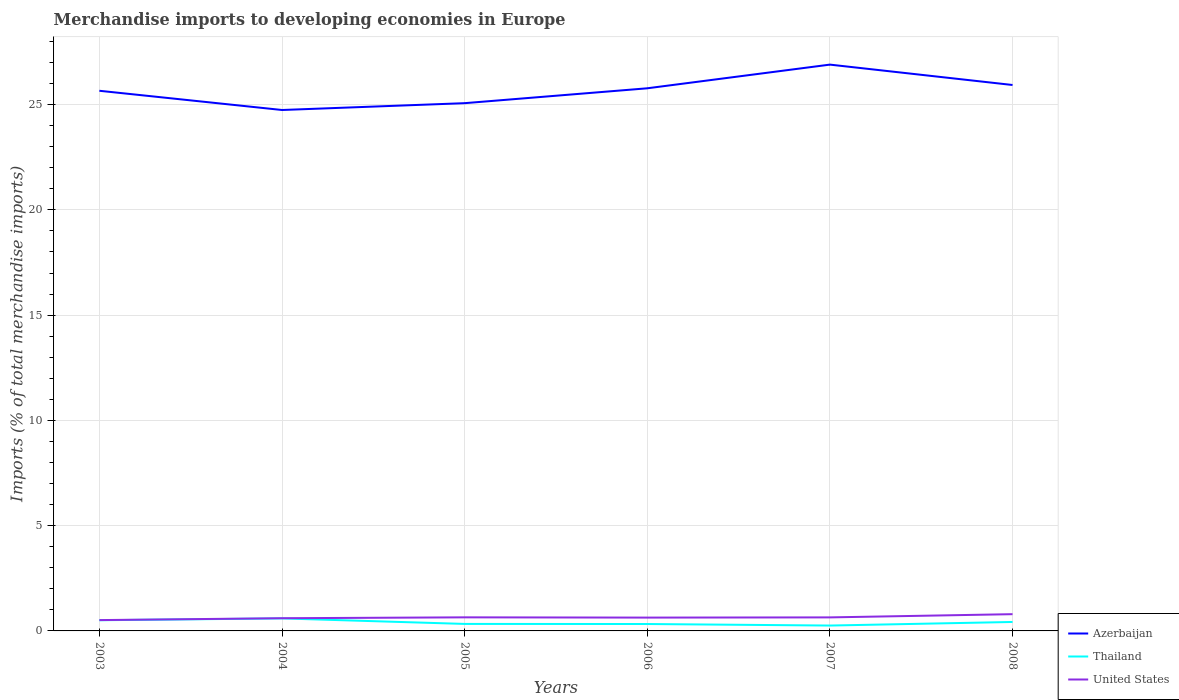Does the line corresponding to Azerbaijan intersect with the line corresponding to Thailand?
Give a very brief answer. No. Is the number of lines equal to the number of legend labels?
Provide a succinct answer. Yes. Across all years, what is the maximum percentage total merchandise imports in Thailand?
Provide a short and direct response. 0.26. In which year was the percentage total merchandise imports in Thailand maximum?
Ensure brevity in your answer.  2007. What is the total percentage total merchandise imports in United States in the graph?
Provide a short and direct response. -0.16. What is the difference between the highest and the second highest percentage total merchandise imports in United States?
Give a very brief answer. 0.28. What is the difference between the highest and the lowest percentage total merchandise imports in Azerbaijan?
Make the answer very short. 3. Is the percentage total merchandise imports in Azerbaijan strictly greater than the percentage total merchandise imports in Thailand over the years?
Give a very brief answer. No. How many lines are there?
Provide a succinct answer. 3. Are the values on the major ticks of Y-axis written in scientific E-notation?
Your answer should be compact. No. How many legend labels are there?
Give a very brief answer. 3. How are the legend labels stacked?
Provide a succinct answer. Vertical. What is the title of the graph?
Ensure brevity in your answer.  Merchandise imports to developing economies in Europe. What is the label or title of the Y-axis?
Offer a very short reply. Imports (% of total merchandise imports). What is the Imports (% of total merchandise imports) in Azerbaijan in 2003?
Provide a succinct answer. 25.66. What is the Imports (% of total merchandise imports) in Thailand in 2003?
Provide a short and direct response. 0.51. What is the Imports (% of total merchandise imports) of United States in 2003?
Your response must be concise. 0.51. What is the Imports (% of total merchandise imports) in Azerbaijan in 2004?
Give a very brief answer. 24.74. What is the Imports (% of total merchandise imports) in Thailand in 2004?
Provide a short and direct response. 0.59. What is the Imports (% of total merchandise imports) in United States in 2004?
Keep it short and to the point. 0.6. What is the Imports (% of total merchandise imports) of Azerbaijan in 2005?
Keep it short and to the point. 25.07. What is the Imports (% of total merchandise imports) of Thailand in 2005?
Provide a succinct answer. 0.33. What is the Imports (% of total merchandise imports) of United States in 2005?
Your response must be concise. 0.65. What is the Imports (% of total merchandise imports) of Azerbaijan in 2006?
Offer a terse response. 25.77. What is the Imports (% of total merchandise imports) in Thailand in 2006?
Offer a very short reply. 0.33. What is the Imports (% of total merchandise imports) in United States in 2006?
Your answer should be compact. 0.63. What is the Imports (% of total merchandise imports) in Azerbaijan in 2007?
Make the answer very short. 26.9. What is the Imports (% of total merchandise imports) in Thailand in 2007?
Your response must be concise. 0.26. What is the Imports (% of total merchandise imports) of United States in 2007?
Your answer should be compact. 0.64. What is the Imports (% of total merchandise imports) in Azerbaijan in 2008?
Make the answer very short. 25.93. What is the Imports (% of total merchandise imports) in Thailand in 2008?
Provide a succinct answer. 0.43. What is the Imports (% of total merchandise imports) of United States in 2008?
Your answer should be compact. 0.8. Across all years, what is the maximum Imports (% of total merchandise imports) of Azerbaijan?
Your response must be concise. 26.9. Across all years, what is the maximum Imports (% of total merchandise imports) of Thailand?
Give a very brief answer. 0.59. Across all years, what is the maximum Imports (% of total merchandise imports) of United States?
Ensure brevity in your answer.  0.8. Across all years, what is the minimum Imports (% of total merchandise imports) in Azerbaijan?
Provide a succinct answer. 24.74. Across all years, what is the minimum Imports (% of total merchandise imports) in Thailand?
Your response must be concise. 0.26. Across all years, what is the minimum Imports (% of total merchandise imports) of United States?
Give a very brief answer. 0.51. What is the total Imports (% of total merchandise imports) in Azerbaijan in the graph?
Give a very brief answer. 154.07. What is the total Imports (% of total merchandise imports) of Thailand in the graph?
Keep it short and to the point. 2.44. What is the total Imports (% of total merchandise imports) in United States in the graph?
Give a very brief answer. 3.83. What is the difference between the Imports (% of total merchandise imports) of Azerbaijan in 2003 and that in 2004?
Your response must be concise. 0.91. What is the difference between the Imports (% of total merchandise imports) in Thailand in 2003 and that in 2004?
Your response must be concise. -0.09. What is the difference between the Imports (% of total merchandise imports) in United States in 2003 and that in 2004?
Your response must be concise. -0.09. What is the difference between the Imports (% of total merchandise imports) of Azerbaijan in 2003 and that in 2005?
Ensure brevity in your answer.  0.59. What is the difference between the Imports (% of total merchandise imports) in Thailand in 2003 and that in 2005?
Ensure brevity in your answer.  0.18. What is the difference between the Imports (% of total merchandise imports) of United States in 2003 and that in 2005?
Provide a short and direct response. -0.13. What is the difference between the Imports (% of total merchandise imports) of Azerbaijan in 2003 and that in 2006?
Provide a short and direct response. -0.12. What is the difference between the Imports (% of total merchandise imports) in Thailand in 2003 and that in 2006?
Your response must be concise. 0.18. What is the difference between the Imports (% of total merchandise imports) in United States in 2003 and that in 2006?
Your response must be concise. -0.12. What is the difference between the Imports (% of total merchandise imports) in Azerbaijan in 2003 and that in 2007?
Offer a very short reply. -1.24. What is the difference between the Imports (% of total merchandise imports) in Thailand in 2003 and that in 2007?
Ensure brevity in your answer.  0.25. What is the difference between the Imports (% of total merchandise imports) in United States in 2003 and that in 2007?
Your answer should be compact. -0.13. What is the difference between the Imports (% of total merchandise imports) of Azerbaijan in 2003 and that in 2008?
Ensure brevity in your answer.  -0.27. What is the difference between the Imports (% of total merchandise imports) in Thailand in 2003 and that in 2008?
Offer a very short reply. 0.08. What is the difference between the Imports (% of total merchandise imports) of United States in 2003 and that in 2008?
Make the answer very short. -0.28. What is the difference between the Imports (% of total merchandise imports) in Azerbaijan in 2004 and that in 2005?
Your answer should be very brief. -0.32. What is the difference between the Imports (% of total merchandise imports) in Thailand in 2004 and that in 2005?
Keep it short and to the point. 0.26. What is the difference between the Imports (% of total merchandise imports) in United States in 2004 and that in 2005?
Your answer should be very brief. -0.04. What is the difference between the Imports (% of total merchandise imports) in Azerbaijan in 2004 and that in 2006?
Give a very brief answer. -1.03. What is the difference between the Imports (% of total merchandise imports) of Thailand in 2004 and that in 2006?
Provide a succinct answer. 0.27. What is the difference between the Imports (% of total merchandise imports) of United States in 2004 and that in 2006?
Your response must be concise. -0.03. What is the difference between the Imports (% of total merchandise imports) in Azerbaijan in 2004 and that in 2007?
Ensure brevity in your answer.  -2.16. What is the difference between the Imports (% of total merchandise imports) of Thailand in 2004 and that in 2007?
Your response must be concise. 0.34. What is the difference between the Imports (% of total merchandise imports) of United States in 2004 and that in 2007?
Provide a short and direct response. -0.04. What is the difference between the Imports (% of total merchandise imports) of Azerbaijan in 2004 and that in 2008?
Make the answer very short. -1.19. What is the difference between the Imports (% of total merchandise imports) in Thailand in 2004 and that in 2008?
Provide a short and direct response. 0.17. What is the difference between the Imports (% of total merchandise imports) in United States in 2004 and that in 2008?
Provide a succinct answer. -0.19. What is the difference between the Imports (% of total merchandise imports) in Azerbaijan in 2005 and that in 2006?
Ensure brevity in your answer.  -0.71. What is the difference between the Imports (% of total merchandise imports) in Thailand in 2005 and that in 2006?
Keep it short and to the point. 0. What is the difference between the Imports (% of total merchandise imports) in United States in 2005 and that in 2006?
Make the answer very short. 0.01. What is the difference between the Imports (% of total merchandise imports) of Azerbaijan in 2005 and that in 2007?
Your response must be concise. -1.83. What is the difference between the Imports (% of total merchandise imports) in Thailand in 2005 and that in 2007?
Ensure brevity in your answer.  0.08. What is the difference between the Imports (% of total merchandise imports) in United States in 2005 and that in 2007?
Offer a very short reply. 0. What is the difference between the Imports (% of total merchandise imports) of Azerbaijan in 2005 and that in 2008?
Offer a very short reply. -0.86. What is the difference between the Imports (% of total merchandise imports) of Thailand in 2005 and that in 2008?
Your answer should be compact. -0.09. What is the difference between the Imports (% of total merchandise imports) in United States in 2005 and that in 2008?
Ensure brevity in your answer.  -0.15. What is the difference between the Imports (% of total merchandise imports) of Azerbaijan in 2006 and that in 2007?
Your answer should be compact. -1.12. What is the difference between the Imports (% of total merchandise imports) in Thailand in 2006 and that in 2007?
Your answer should be very brief. 0.07. What is the difference between the Imports (% of total merchandise imports) of United States in 2006 and that in 2007?
Offer a very short reply. -0.01. What is the difference between the Imports (% of total merchandise imports) in Azerbaijan in 2006 and that in 2008?
Your answer should be compact. -0.16. What is the difference between the Imports (% of total merchandise imports) in Thailand in 2006 and that in 2008?
Your answer should be compact. -0.1. What is the difference between the Imports (% of total merchandise imports) of United States in 2006 and that in 2008?
Your answer should be very brief. -0.16. What is the difference between the Imports (% of total merchandise imports) of Azerbaijan in 2007 and that in 2008?
Provide a succinct answer. 0.97. What is the difference between the Imports (% of total merchandise imports) of Thailand in 2007 and that in 2008?
Offer a very short reply. -0.17. What is the difference between the Imports (% of total merchandise imports) in United States in 2007 and that in 2008?
Ensure brevity in your answer.  -0.15. What is the difference between the Imports (% of total merchandise imports) in Azerbaijan in 2003 and the Imports (% of total merchandise imports) in Thailand in 2004?
Your answer should be very brief. 25.06. What is the difference between the Imports (% of total merchandise imports) in Azerbaijan in 2003 and the Imports (% of total merchandise imports) in United States in 2004?
Offer a very short reply. 25.05. What is the difference between the Imports (% of total merchandise imports) of Thailand in 2003 and the Imports (% of total merchandise imports) of United States in 2004?
Your response must be concise. -0.1. What is the difference between the Imports (% of total merchandise imports) in Azerbaijan in 2003 and the Imports (% of total merchandise imports) in Thailand in 2005?
Ensure brevity in your answer.  25.32. What is the difference between the Imports (% of total merchandise imports) in Azerbaijan in 2003 and the Imports (% of total merchandise imports) in United States in 2005?
Offer a terse response. 25.01. What is the difference between the Imports (% of total merchandise imports) of Thailand in 2003 and the Imports (% of total merchandise imports) of United States in 2005?
Provide a short and direct response. -0.14. What is the difference between the Imports (% of total merchandise imports) in Azerbaijan in 2003 and the Imports (% of total merchandise imports) in Thailand in 2006?
Your answer should be compact. 25.33. What is the difference between the Imports (% of total merchandise imports) of Azerbaijan in 2003 and the Imports (% of total merchandise imports) of United States in 2006?
Ensure brevity in your answer.  25.02. What is the difference between the Imports (% of total merchandise imports) of Thailand in 2003 and the Imports (% of total merchandise imports) of United States in 2006?
Your answer should be very brief. -0.13. What is the difference between the Imports (% of total merchandise imports) in Azerbaijan in 2003 and the Imports (% of total merchandise imports) in Thailand in 2007?
Your answer should be compact. 25.4. What is the difference between the Imports (% of total merchandise imports) of Azerbaijan in 2003 and the Imports (% of total merchandise imports) of United States in 2007?
Keep it short and to the point. 25.01. What is the difference between the Imports (% of total merchandise imports) in Thailand in 2003 and the Imports (% of total merchandise imports) in United States in 2007?
Your answer should be very brief. -0.13. What is the difference between the Imports (% of total merchandise imports) of Azerbaijan in 2003 and the Imports (% of total merchandise imports) of Thailand in 2008?
Your answer should be compact. 25.23. What is the difference between the Imports (% of total merchandise imports) in Azerbaijan in 2003 and the Imports (% of total merchandise imports) in United States in 2008?
Give a very brief answer. 24.86. What is the difference between the Imports (% of total merchandise imports) of Thailand in 2003 and the Imports (% of total merchandise imports) of United States in 2008?
Offer a very short reply. -0.29. What is the difference between the Imports (% of total merchandise imports) of Azerbaijan in 2004 and the Imports (% of total merchandise imports) of Thailand in 2005?
Your response must be concise. 24.41. What is the difference between the Imports (% of total merchandise imports) in Azerbaijan in 2004 and the Imports (% of total merchandise imports) in United States in 2005?
Provide a succinct answer. 24.1. What is the difference between the Imports (% of total merchandise imports) of Thailand in 2004 and the Imports (% of total merchandise imports) of United States in 2005?
Your answer should be very brief. -0.05. What is the difference between the Imports (% of total merchandise imports) in Azerbaijan in 2004 and the Imports (% of total merchandise imports) in Thailand in 2006?
Keep it short and to the point. 24.42. What is the difference between the Imports (% of total merchandise imports) in Azerbaijan in 2004 and the Imports (% of total merchandise imports) in United States in 2006?
Offer a terse response. 24.11. What is the difference between the Imports (% of total merchandise imports) of Thailand in 2004 and the Imports (% of total merchandise imports) of United States in 2006?
Offer a terse response. -0.04. What is the difference between the Imports (% of total merchandise imports) in Azerbaijan in 2004 and the Imports (% of total merchandise imports) in Thailand in 2007?
Ensure brevity in your answer.  24.49. What is the difference between the Imports (% of total merchandise imports) in Azerbaijan in 2004 and the Imports (% of total merchandise imports) in United States in 2007?
Your answer should be compact. 24.1. What is the difference between the Imports (% of total merchandise imports) in Thailand in 2004 and the Imports (% of total merchandise imports) in United States in 2007?
Provide a short and direct response. -0.05. What is the difference between the Imports (% of total merchandise imports) of Azerbaijan in 2004 and the Imports (% of total merchandise imports) of Thailand in 2008?
Your answer should be compact. 24.32. What is the difference between the Imports (% of total merchandise imports) of Azerbaijan in 2004 and the Imports (% of total merchandise imports) of United States in 2008?
Make the answer very short. 23.95. What is the difference between the Imports (% of total merchandise imports) of Thailand in 2004 and the Imports (% of total merchandise imports) of United States in 2008?
Your response must be concise. -0.2. What is the difference between the Imports (% of total merchandise imports) of Azerbaijan in 2005 and the Imports (% of total merchandise imports) of Thailand in 2006?
Offer a terse response. 24.74. What is the difference between the Imports (% of total merchandise imports) in Azerbaijan in 2005 and the Imports (% of total merchandise imports) in United States in 2006?
Make the answer very short. 24.43. What is the difference between the Imports (% of total merchandise imports) of Thailand in 2005 and the Imports (% of total merchandise imports) of United States in 2006?
Ensure brevity in your answer.  -0.3. What is the difference between the Imports (% of total merchandise imports) of Azerbaijan in 2005 and the Imports (% of total merchandise imports) of Thailand in 2007?
Keep it short and to the point. 24.81. What is the difference between the Imports (% of total merchandise imports) of Azerbaijan in 2005 and the Imports (% of total merchandise imports) of United States in 2007?
Give a very brief answer. 24.42. What is the difference between the Imports (% of total merchandise imports) of Thailand in 2005 and the Imports (% of total merchandise imports) of United States in 2007?
Your response must be concise. -0.31. What is the difference between the Imports (% of total merchandise imports) in Azerbaijan in 2005 and the Imports (% of total merchandise imports) in Thailand in 2008?
Your answer should be compact. 24.64. What is the difference between the Imports (% of total merchandise imports) of Azerbaijan in 2005 and the Imports (% of total merchandise imports) of United States in 2008?
Keep it short and to the point. 24.27. What is the difference between the Imports (% of total merchandise imports) of Thailand in 2005 and the Imports (% of total merchandise imports) of United States in 2008?
Provide a succinct answer. -0.46. What is the difference between the Imports (% of total merchandise imports) in Azerbaijan in 2006 and the Imports (% of total merchandise imports) in Thailand in 2007?
Provide a short and direct response. 25.52. What is the difference between the Imports (% of total merchandise imports) of Azerbaijan in 2006 and the Imports (% of total merchandise imports) of United States in 2007?
Make the answer very short. 25.13. What is the difference between the Imports (% of total merchandise imports) in Thailand in 2006 and the Imports (% of total merchandise imports) in United States in 2007?
Your answer should be compact. -0.31. What is the difference between the Imports (% of total merchandise imports) of Azerbaijan in 2006 and the Imports (% of total merchandise imports) of Thailand in 2008?
Ensure brevity in your answer.  25.35. What is the difference between the Imports (% of total merchandise imports) of Azerbaijan in 2006 and the Imports (% of total merchandise imports) of United States in 2008?
Your answer should be very brief. 24.98. What is the difference between the Imports (% of total merchandise imports) in Thailand in 2006 and the Imports (% of total merchandise imports) in United States in 2008?
Ensure brevity in your answer.  -0.47. What is the difference between the Imports (% of total merchandise imports) in Azerbaijan in 2007 and the Imports (% of total merchandise imports) in Thailand in 2008?
Offer a very short reply. 26.47. What is the difference between the Imports (% of total merchandise imports) of Azerbaijan in 2007 and the Imports (% of total merchandise imports) of United States in 2008?
Provide a short and direct response. 26.1. What is the difference between the Imports (% of total merchandise imports) of Thailand in 2007 and the Imports (% of total merchandise imports) of United States in 2008?
Your response must be concise. -0.54. What is the average Imports (% of total merchandise imports) of Azerbaijan per year?
Ensure brevity in your answer.  25.68. What is the average Imports (% of total merchandise imports) in Thailand per year?
Your answer should be compact. 0.41. What is the average Imports (% of total merchandise imports) in United States per year?
Make the answer very short. 0.64. In the year 2003, what is the difference between the Imports (% of total merchandise imports) of Azerbaijan and Imports (% of total merchandise imports) of Thailand?
Provide a succinct answer. 25.15. In the year 2003, what is the difference between the Imports (% of total merchandise imports) in Azerbaijan and Imports (% of total merchandise imports) in United States?
Your response must be concise. 25.14. In the year 2003, what is the difference between the Imports (% of total merchandise imports) in Thailand and Imports (% of total merchandise imports) in United States?
Provide a succinct answer. -0.01. In the year 2004, what is the difference between the Imports (% of total merchandise imports) of Azerbaijan and Imports (% of total merchandise imports) of Thailand?
Your response must be concise. 24.15. In the year 2004, what is the difference between the Imports (% of total merchandise imports) of Azerbaijan and Imports (% of total merchandise imports) of United States?
Offer a terse response. 24.14. In the year 2004, what is the difference between the Imports (% of total merchandise imports) of Thailand and Imports (% of total merchandise imports) of United States?
Give a very brief answer. -0.01. In the year 2005, what is the difference between the Imports (% of total merchandise imports) of Azerbaijan and Imports (% of total merchandise imports) of Thailand?
Your response must be concise. 24.73. In the year 2005, what is the difference between the Imports (% of total merchandise imports) of Azerbaijan and Imports (% of total merchandise imports) of United States?
Your answer should be compact. 24.42. In the year 2005, what is the difference between the Imports (% of total merchandise imports) in Thailand and Imports (% of total merchandise imports) in United States?
Your answer should be very brief. -0.31. In the year 2006, what is the difference between the Imports (% of total merchandise imports) of Azerbaijan and Imports (% of total merchandise imports) of Thailand?
Provide a succinct answer. 25.45. In the year 2006, what is the difference between the Imports (% of total merchandise imports) of Azerbaijan and Imports (% of total merchandise imports) of United States?
Your answer should be compact. 25.14. In the year 2006, what is the difference between the Imports (% of total merchandise imports) in Thailand and Imports (% of total merchandise imports) in United States?
Your response must be concise. -0.31. In the year 2007, what is the difference between the Imports (% of total merchandise imports) in Azerbaijan and Imports (% of total merchandise imports) in Thailand?
Keep it short and to the point. 26.64. In the year 2007, what is the difference between the Imports (% of total merchandise imports) in Azerbaijan and Imports (% of total merchandise imports) in United States?
Offer a terse response. 26.26. In the year 2007, what is the difference between the Imports (% of total merchandise imports) of Thailand and Imports (% of total merchandise imports) of United States?
Offer a very short reply. -0.39. In the year 2008, what is the difference between the Imports (% of total merchandise imports) of Azerbaijan and Imports (% of total merchandise imports) of Thailand?
Ensure brevity in your answer.  25.51. In the year 2008, what is the difference between the Imports (% of total merchandise imports) in Azerbaijan and Imports (% of total merchandise imports) in United States?
Your answer should be compact. 25.14. In the year 2008, what is the difference between the Imports (% of total merchandise imports) of Thailand and Imports (% of total merchandise imports) of United States?
Provide a succinct answer. -0.37. What is the ratio of the Imports (% of total merchandise imports) in Azerbaijan in 2003 to that in 2004?
Ensure brevity in your answer.  1.04. What is the ratio of the Imports (% of total merchandise imports) in Thailand in 2003 to that in 2004?
Your response must be concise. 0.85. What is the ratio of the Imports (% of total merchandise imports) in United States in 2003 to that in 2004?
Keep it short and to the point. 0.85. What is the ratio of the Imports (% of total merchandise imports) of Azerbaijan in 2003 to that in 2005?
Make the answer very short. 1.02. What is the ratio of the Imports (% of total merchandise imports) in Thailand in 2003 to that in 2005?
Keep it short and to the point. 1.53. What is the ratio of the Imports (% of total merchandise imports) in United States in 2003 to that in 2005?
Offer a very short reply. 0.8. What is the ratio of the Imports (% of total merchandise imports) of Azerbaijan in 2003 to that in 2006?
Provide a succinct answer. 1. What is the ratio of the Imports (% of total merchandise imports) in Thailand in 2003 to that in 2006?
Keep it short and to the point. 1.55. What is the ratio of the Imports (% of total merchandise imports) of United States in 2003 to that in 2006?
Provide a short and direct response. 0.81. What is the ratio of the Imports (% of total merchandise imports) in Azerbaijan in 2003 to that in 2007?
Make the answer very short. 0.95. What is the ratio of the Imports (% of total merchandise imports) of Thailand in 2003 to that in 2007?
Make the answer very short. 1.99. What is the ratio of the Imports (% of total merchandise imports) of United States in 2003 to that in 2007?
Offer a very short reply. 0.8. What is the ratio of the Imports (% of total merchandise imports) in Thailand in 2003 to that in 2008?
Your response must be concise. 1.19. What is the ratio of the Imports (% of total merchandise imports) of United States in 2003 to that in 2008?
Ensure brevity in your answer.  0.65. What is the ratio of the Imports (% of total merchandise imports) in Azerbaijan in 2004 to that in 2005?
Your answer should be very brief. 0.99. What is the ratio of the Imports (% of total merchandise imports) in Thailand in 2004 to that in 2005?
Keep it short and to the point. 1.79. What is the ratio of the Imports (% of total merchandise imports) in United States in 2004 to that in 2005?
Your answer should be compact. 0.94. What is the ratio of the Imports (% of total merchandise imports) of Thailand in 2004 to that in 2006?
Ensure brevity in your answer.  1.81. What is the ratio of the Imports (% of total merchandise imports) in United States in 2004 to that in 2006?
Keep it short and to the point. 0.95. What is the ratio of the Imports (% of total merchandise imports) in Azerbaijan in 2004 to that in 2007?
Offer a very short reply. 0.92. What is the ratio of the Imports (% of total merchandise imports) of Thailand in 2004 to that in 2007?
Your answer should be compact. 2.33. What is the ratio of the Imports (% of total merchandise imports) of United States in 2004 to that in 2007?
Your answer should be very brief. 0.94. What is the ratio of the Imports (% of total merchandise imports) in Azerbaijan in 2004 to that in 2008?
Give a very brief answer. 0.95. What is the ratio of the Imports (% of total merchandise imports) of Thailand in 2004 to that in 2008?
Ensure brevity in your answer.  1.4. What is the ratio of the Imports (% of total merchandise imports) in United States in 2004 to that in 2008?
Ensure brevity in your answer.  0.76. What is the ratio of the Imports (% of total merchandise imports) of Azerbaijan in 2005 to that in 2006?
Make the answer very short. 0.97. What is the ratio of the Imports (% of total merchandise imports) in Thailand in 2005 to that in 2006?
Ensure brevity in your answer.  1.01. What is the ratio of the Imports (% of total merchandise imports) of United States in 2005 to that in 2006?
Provide a succinct answer. 1.02. What is the ratio of the Imports (% of total merchandise imports) of Azerbaijan in 2005 to that in 2007?
Make the answer very short. 0.93. What is the ratio of the Imports (% of total merchandise imports) of Thailand in 2005 to that in 2007?
Offer a very short reply. 1.3. What is the ratio of the Imports (% of total merchandise imports) in Azerbaijan in 2005 to that in 2008?
Make the answer very short. 0.97. What is the ratio of the Imports (% of total merchandise imports) in Thailand in 2005 to that in 2008?
Provide a short and direct response. 0.78. What is the ratio of the Imports (% of total merchandise imports) in United States in 2005 to that in 2008?
Your response must be concise. 0.81. What is the ratio of the Imports (% of total merchandise imports) of Azerbaijan in 2006 to that in 2007?
Your answer should be very brief. 0.96. What is the ratio of the Imports (% of total merchandise imports) in United States in 2006 to that in 2007?
Your answer should be compact. 0.99. What is the ratio of the Imports (% of total merchandise imports) of Thailand in 2006 to that in 2008?
Give a very brief answer. 0.77. What is the ratio of the Imports (% of total merchandise imports) in United States in 2006 to that in 2008?
Offer a very short reply. 0.8. What is the ratio of the Imports (% of total merchandise imports) in Azerbaijan in 2007 to that in 2008?
Offer a very short reply. 1.04. What is the ratio of the Imports (% of total merchandise imports) of Thailand in 2007 to that in 2008?
Make the answer very short. 0.6. What is the ratio of the Imports (% of total merchandise imports) of United States in 2007 to that in 2008?
Ensure brevity in your answer.  0.81. What is the difference between the highest and the second highest Imports (% of total merchandise imports) in Azerbaijan?
Offer a terse response. 0.97. What is the difference between the highest and the second highest Imports (% of total merchandise imports) of Thailand?
Provide a short and direct response. 0.09. What is the difference between the highest and the second highest Imports (% of total merchandise imports) of United States?
Your answer should be very brief. 0.15. What is the difference between the highest and the lowest Imports (% of total merchandise imports) in Azerbaijan?
Your answer should be compact. 2.16. What is the difference between the highest and the lowest Imports (% of total merchandise imports) in Thailand?
Ensure brevity in your answer.  0.34. What is the difference between the highest and the lowest Imports (% of total merchandise imports) of United States?
Provide a succinct answer. 0.28. 